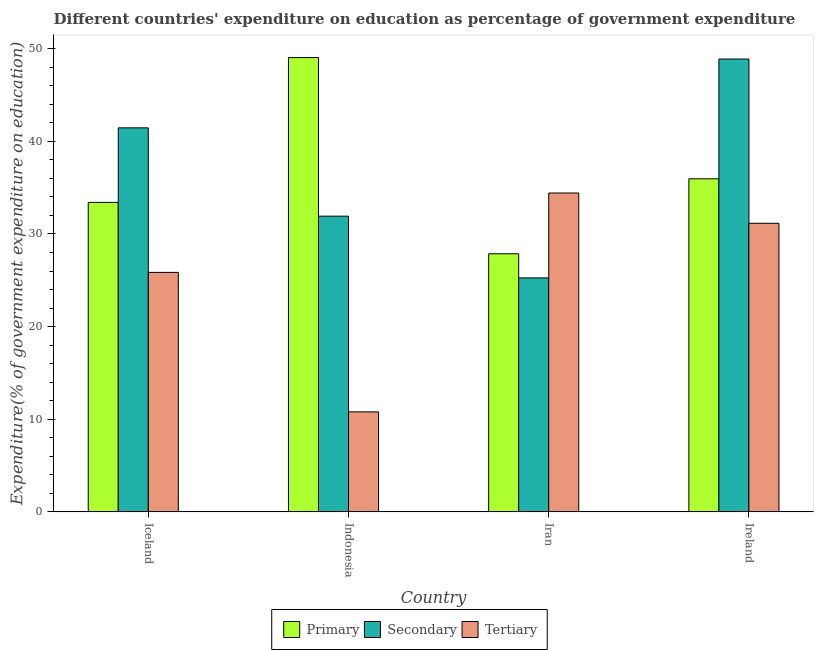How many different coloured bars are there?
Your response must be concise. 3. Are the number of bars per tick equal to the number of legend labels?
Ensure brevity in your answer.  Yes. Are the number of bars on each tick of the X-axis equal?
Make the answer very short. Yes. How many bars are there on the 1st tick from the left?
Offer a terse response. 3. What is the expenditure on primary education in Indonesia?
Provide a short and direct response. 49.04. Across all countries, what is the maximum expenditure on tertiary education?
Your answer should be compact. 34.42. Across all countries, what is the minimum expenditure on secondary education?
Ensure brevity in your answer.  25.26. In which country was the expenditure on tertiary education maximum?
Offer a very short reply. Iran. In which country was the expenditure on secondary education minimum?
Provide a short and direct response. Iran. What is the total expenditure on secondary education in the graph?
Provide a short and direct response. 147.53. What is the difference between the expenditure on primary education in Iceland and that in Indonesia?
Keep it short and to the point. -15.63. What is the difference between the expenditure on secondary education in Indonesia and the expenditure on primary education in Iceland?
Give a very brief answer. -1.49. What is the average expenditure on secondary education per country?
Offer a terse response. 36.88. What is the difference between the expenditure on primary education and expenditure on tertiary education in Iran?
Keep it short and to the point. -6.56. What is the ratio of the expenditure on primary education in Iceland to that in Ireland?
Offer a terse response. 0.93. Is the expenditure on secondary education in Iceland less than that in Iran?
Make the answer very short. No. Is the difference between the expenditure on secondary education in Indonesia and Iran greater than the difference between the expenditure on primary education in Indonesia and Iran?
Give a very brief answer. No. What is the difference between the highest and the second highest expenditure on secondary education?
Your response must be concise. 7.43. What is the difference between the highest and the lowest expenditure on primary education?
Offer a very short reply. 21.18. Is the sum of the expenditure on primary education in Iran and Ireland greater than the maximum expenditure on tertiary education across all countries?
Ensure brevity in your answer.  Yes. What does the 1st bar from the left in Iceland represents?
Give a very brief answer. Primary. What does the 3rd bar from the right in Iran represents?
Offer a very short reply. Primary. How many bars are there?
Ensure brevity in your answer.  12. How many countries are there in the graph?
Your response must be concise. 4. Are the values on the major ticks of Y-axis written in scientific E-notation?
Provide a succinct answer. No. Does the graph contain any zero values?
Provide a succinct answer. No. How many legend labels are there?
Ensure brevity in your answer.  3. What is the title of the graph?
Your response must be concise. Different countries' expenditure on education as percentage of government expenditure. Does "Labor Tax" appear as one of the legend labels in the graph?
Give a very brief answer. No. What is the label or title of the X-axis?
Your answer should be compact. Country. What is the label or title of the Y-axis?
Your response must be concise. Expenditure(% of government expenditure on education). What is the Expenditure(% of government expenditure on education) of Primary in Iceland?
Your answer should be very brief. 33.41. What is the Expenditure(% of government expenditure on education) in Secondary in Iceland?
Ensure brevity in your answer.  41.46. What is the Expenditure(% of government expenditure on education) in Tertiary in Iceland?
Offer a very short reply. 25.85. What is the Expenditure(% of government expenditure on education) of Primary in Indonesia?
Make the answer very short. 49.04. What is the Expenditure(% of government expenditure on education) in Secondary in Indonesia?
Provide a short and direct response. 31.92. What is the Expenditure(% of government expenditure on education) of Tertiary in Indonesia?
Give a very brief answer. 10.8. What is the Expenditure(% of government expenditure on education) in Primary in Iran?
Give a very brief answer. 27.86. What is the Expenditure(% of government expenditure on education) of Secondary in Iran?
Your answer should be compact. 25.26. What is the Expenditure(% of government expenditure on education) of Tertiary in Iran?
Provide a succinct answer. 34.42. What is the Expenditure(% of government expenditure on education) of Primary in Ireland?
Your answer should be very brief. 35.96. What is the Expenditure(% of government expenditure on education) of Secondary in Ireland?
Your response must be concise. 48.89. What is the Expenditure(% of government expenditure on education) in Tertiary in Ireland?
Keep it short and to the point. 31.16. Across all countries, what is the maximum Expenditure(% of government expenditure on education) of Primary?
Your answer should be very brief. 49.04. Across all countries, what is the maximum Expenditure(% of government expenditure on education) in Secondary?
Your response must be concise. 48.89. Across all countries, what is the maximum Expenditure(% of government expenditure on education) of Tertiary?
Your response must be concise. 34.42. Across all countries, what is the minimum Expenditure(% of government expenditure on education) of Primary?
Keep it short and to the point. 27.86. Across all countries, what is the minimum Expenditure(% of government expenditure on education) of Secondary?
Make the answer very short. 25.26. Across all countries, what is the minimum Expenditure(% of government expenditure on education) in Tertiary?
Provide a succinct answer. 10.8. What is the total Expenditure(% of government expenditure on education) of Primary in the graph?
Provide a short and direct response. 146.28. What is the total Expenditure(% of government expenditure on education) in Secondary in the graph?
Make the answer very short. 147.53. What is the total Expenditure(% of government expenditure on education) in Tertiary in the graph?
Provide a succinct answer. 102.23. What is the difference between the Expenditure(% of government expenditure on education) of Primary in Iceland and that in Indonesia?
Offer a very short reply. -15.63. What is the difference between the Expenditure(% of government expenditure on education) of Secondary in Iceland and that in Indonesia?
Make the answer very short. 9.53. What is the difference between the Expenditure(% of government expenditure on education) in Tertiary in Iceland and that in Indonesia?
Your answer should be very brief. 15.06. What is the difference between the Expenditure(% of government expenditure on education) of Primary in Iceland and that in Iran?
Offer a terse response. 5.55. What is the difference between the Expenditure(% of government expenditure on education) of Secondary in Iceland and that in Iran?
Provide a succinct answer. 16.2. What is the difference between the Expenditure(% of government expenditure on education) in Tertiary in Iceland and that in Iran?
Offer a very short reply. -8.57. What is the difference between the Expenditure(% of government expenditure on education) of Primary in Iceland and that in Ireland?
Provide a short and direct response. -2.55. What is the difference between the Expenditure(% of government expenditure on education) in Secondary in Iceland and that in Ireland?
Your answer should be very brief. -7.43. What is the difference between the Expenditure(% of government expenditure on education) in Tertiary in Iceland and that in Ireland?
Your response must be concise. -5.3. What is the difference between the Expenditure(% of government expenditure on education) of Primary in Indonesia and that in Iran?
Provide a short and direct response. 21.18. What is the difference between the Expenditure(% of government expenditure on education) of Secondary in Indonesia and that in Iran?
Provide a succinct answer. 6.66. What is the difference between the Expenditure(% of government expenditure on education) in Tertiary in Indonesia and that in Iran?
Ensure brevity in your answer.  -23.63. What is the difference between the Expenditure(% of government expenditure on education) of Primary in Indonesia and that in Ireland?
Ensure brevity in your answer.  13.09. What is the difference between the Expenditure(% of government expenditure on education) of Secondary in Indonesia and that in Ireland?
Keep it short and to the point. -16.96. What is the difference between the Expenditure(% of government expenditure on education) in Tertiary in Indonesia and that in Ireland?
Give a very brief answer. -20.36. What is the difference between the Expenditure(% of government expenditure on education) in Primary in Iran and that in Ireland?
Keep it short and to the point. -8.09. What is the difference between the Expenditure(% of government expenditure on education) of Secondary in Iran and that in Ireland?
Offer a very short reply. -23.63. What is the difference between the Expenditure(% of government expenditure on education) of Tertiary in Iran and that in Ireland?
Ensure brevity in your answer.  3.27. What is the difference between the Expenditure(% of government expenditure on education) in Primary in Iceland and the Expenditure(% of government expenditure on education) in Secondary in Indonesia?
Offer a terse response. 1.49. What is the difference between the Expenditure(% of government expenditure on education) of Primary in Iceland and the Expenditure(% of government expenditure on education) of Tertiary in Indonesia?
Ensure brevity in your answer.  22.62. What is the difference between the Expenditure(% of government expenditure on education) of Secondary in Iceland and the Expenditure(% of government expenditure on education) of Tertiary in Indonesia?
Give a very brief answer. 30.66. What is the difference between the Expenditure(% of government expenditure on education) in Primary in Iceland and the Expenditure(% of government expenditure on education) in Secondary in Iran?
Ensure brevity in your answer.  8.15. What is the difference between the Expenditure(% of government expenditure on education) in Primary in Iceland and the Expenditure(% of government expenditure on education) in Tertiary in Iran?
Offer a very short reply. -1.01. What is the difference between the Expenditure(% of government expenditure on education) in Secondary in Iceland and the Expenditure(% of government expenditure on education) in Tertiary in Iran?
Make the answer very short. 7.03. What is the difference between the Expenditure(% of government expenditure on education) of Primary in Iceland and the Expenditure(% of government expenditure on education) of Secondary in Ireland?
Ensure brevity in your answer.  -15.47. What is the difference between the Expenditure(% of government expenditure on education) of Primary in Iceland and the Expenditure(% of government expenditure on education) of Tertiary in Ireland?
Offer a terse response. 2.26. What is the difference between the Expenditure(% of government expenditure on education) of Secondary in Iceland and the Expenditure(% of government expenditure on education) of Tertiary in Ireland?
Offer a terse response. 10.3. What is the difference between the Expenditure(% of government expenditure on education) of Primary in Indonesia and the Expenditure(% of government expenditure on education) of Secondary in Iran?
Offer a terse response. 23.78. What is the difference between the Expenditure(% of government expenditure on education) in Primary in Indonesia and the Expenditure(% of government expenditure on education) in Tertiary in Iran?
Your response must be concise. 14.62. What is the difference between the Expenditure(% of government expenditure on education) in Secondary in Indonesia and the Expenditure(% of government expenditure on education) in Tertiary in Iran?
Provide a succinct answer. -2.5. What is the difference between the Expenditure(% of government expenditure on education) of Primary in Indonesia and the Expenditure(% of government expenditure on education) of Secondary in Ireland?
Your response must be concise. 0.16. What is the difference between the Expenditure(% of government expenditure on education) of Primary in Indonesia and the Expenditure(% of government expenditure on education) of Tertiary in Ireland?
Keep it short and to the point. 17.89. What is the difference between the Expenditure(% of government expenditure on education) of Secondary in Indonesia and the Expenditure(% of government expenditure on education) of Tertiary in Ireland?
Provide a succinct answer. 0.77. What is the difference between the Expenditure(% of government expenditure on education) of Primary in Iran and the Expenditure(% of government expenditure on education) of Secondary in Ireland?
Keep it short and to the point. -21.02. What is the difference between the Expenditure(% of government expenditure on education) in Primary in Iran and the Expenditure(% of government expenditure on education) in Tertiary in Ireland?
Provide a short and direct response. -3.29. What is the difference between the Expenditure(% of government expenditure on education) of Secondary in Iran and the Expenditure(% of government expenditure on education) of Tertiary in Ireland?
Give a very brief answer. -5.9. What is the average Expenditure(% of government expenditure on education) of Primary per country?
Your answer should be compact. 36.57. What is the average Expenditure(% of government expenditure on education) in Secondary per country?
Provide a succinct answer. 36.88. What is the average Expenditure(% of government expenditure on education) in Tertiary per country?
Offer a terse response. 25.56. What is the difference between the Expenditure(% of government expenditure on education) of Primary and Expenditure(% of government expenditure on education) of Secondary in Iceland?
Your answer should be very brief. -8.05. What is the difference between the Expenditure(% of government expenditure on education) in Primary and Expenditure(% of government expenditure on education) in Tertiary in Iceland?
Give a very brief answer. 7.56. What is the difference between the Expenditure(% of government expenditure on education) in Secondary and Expenditure(% of government expenditure on education) in Tertiary in Iceland?
Provide a short and direct response. 15.6. What is the difference between the Expenditure(% of government expenditure on education) of Primary and Expenditure(% of government expenditure on education) of Secondary in Indonesia?
Provide a short and direct response. 17.12. What is the difference between the Expenditure(% of government expenditure on education) of Primary and Expenditure(% of government expenditure on education) of Tertiary in Indonesia?
Your answer should be compact. 38.25. What is the difference between the Expenditure(% of government expenditure on education) in Secondary and Expenditure(% of government expenditure on education) in Tertiary in Indonesia?
Your response must be concise. 21.13. What is the difference between the Expenditure(% of government expenditure on education) in Primary and Expenditure(% of government expenditure on education) in Secondary in Iran?
Offer a very short reply. 2.6. What is the difference between the Expenditure(% of government expenditure on education) of Primary and Expenditure(% of government expenditure on education) of Tertiary in Iran?
Your answer should be compact. -6.56. What is the difference between the Expenditure(% of government expenditure on education) in Secondary and Expenditure(% of government expenditure on education) in Tertiary in Iran?
Provide a succinct answer. -9.16. What is the difference between the Expenditure(% of government expenditure on education) in Primary and Expenditure(% of government expenditure on education) in Secondary in Ireland?
Give a very brief answer. -12.93. What is the difference between the Expenditure(% of government expenditure on education) of Primary and Expenditure(% of government expenditure on education) of Tertiary in Ireland?
Your answer should be compact. 4.8. What is the difference between the Expenditure(% of government expenditure on education) in Secondary and Expenditure(% of government expenditure on education) in Tertiary in Ireland?
Provide a succinct answer. 17.73. What is the ratio of the Expenditure(% of government expenditure on education) of Primary in Iceland to that in Indonesia?
Your response must be concise. 0.68. What is the ratio of the Expenditure(% of government expenditure on education) of Secondary in Iceland to that in Indonesia?
Make the answer very short. 1.3. What is the ratio of the Expenditure(% of government expenditure on education) in Tertiary in Iceland to that in Indonesia?
Ensure brevity in your answer.  2.39. What is the ratio of the Expenditure(% of government expenditure on education) in Primary in Iceland to that in Iran?
Your answer should be compact. 1.2. What is the ratio of the Expenditure(% of government expenditure on education) of Secondary in Iceland to that in Iran?
Offer a very short reply. 1.64. What is the ratio of the Expenditure(% of government expenditure on education) in Tertiary in Iceland to that in Iran?
Provide a short and direct response. 0.75. What is the ratio of the Expenditure(% of government expenditure on education) of Primary in Iceland to that in Ireland?
Your response must be concise. 0.93. What is the ratio of the Expenditure(% of government expenditure on education) in Secondary in Iceland to that in Ireland?
Provide a short and direct response. 0.85. What is the ratio of the Expenditure(% of government expenditure on education) of Tertiary in Iceland to that in Ireland?
Ensure brevity in your answer.  0.83. What is the ratio of the Expenditure(% of government expenditure on education) in Primary in Indonesia to that in Iran?
Your answer should be compact. 1.76. What is the ratio of the Expenditure(% of government expenditure on education) of Secondary in Indonesia to that in Iran?
Ensure brevity in your answer.  1.26. What is the ratio of the Expenditure(% of government expenditure on education) in Tertiary in Indonesia to that in Iran?
Your response must be concise. 0.31. What is the ratio of the Expenditure(% of government expenditure on education) in Primary in Indonesia to that in Ireland?
Your answer should be compact. 1.36. What is the ratio of the Expenditure(% of government expenditure on education) in Secondary in Indonesia to that in Ireland?
Your response must be concise. 0.65. What is the ratio of the Expenditure(% of government expenditure on education) of Tertiary in Indonesia to that in Ireland?
Your answer should be very brief. 0.35. What is the ratio of the Expenditure(% of government expenditure on education) of Primary in Iran to that in Ireland?
Your answer should be very brief. 0.77. What is the ratio of the Expenditure(% of government expenditure on education) in Secondary in Iran to that in Ireland?
Offer a very short reply. 0.52. What is the ratio of the Expenditure(% of government expenditure on education) in Tertiary in Iran to that in Ireland?
Make the answer very short. 1.1. What is the difference between the highest and the second highest Expenditure(% of government expenditure on education) in Primary?
Your answer should be compact. 13.09. What is the difference between the highest and the second highest Expenditure(% of government expenditure on education) of Secondary?
Provide a succinct answer. 7.43. What is the difference between the highest and the second highest Expenditure(% of government expenditure on education) in Tertiary?
Provide a succinct answer. 3.27. What is the difference between the highest and the lowest Expenditure(% of government expenditure on education) of Primary?
Give a very brief answer. 21.18. What is the difference between the highest and the lowest Expenditure(% of government expenditure on education) of Secondary?
Give a very brief answer. 23.63. What is the difference between the highest and the lowest Expenditure(% of government expenditure on education) in Tertiary?
Your answer should be compact. 23.63. 